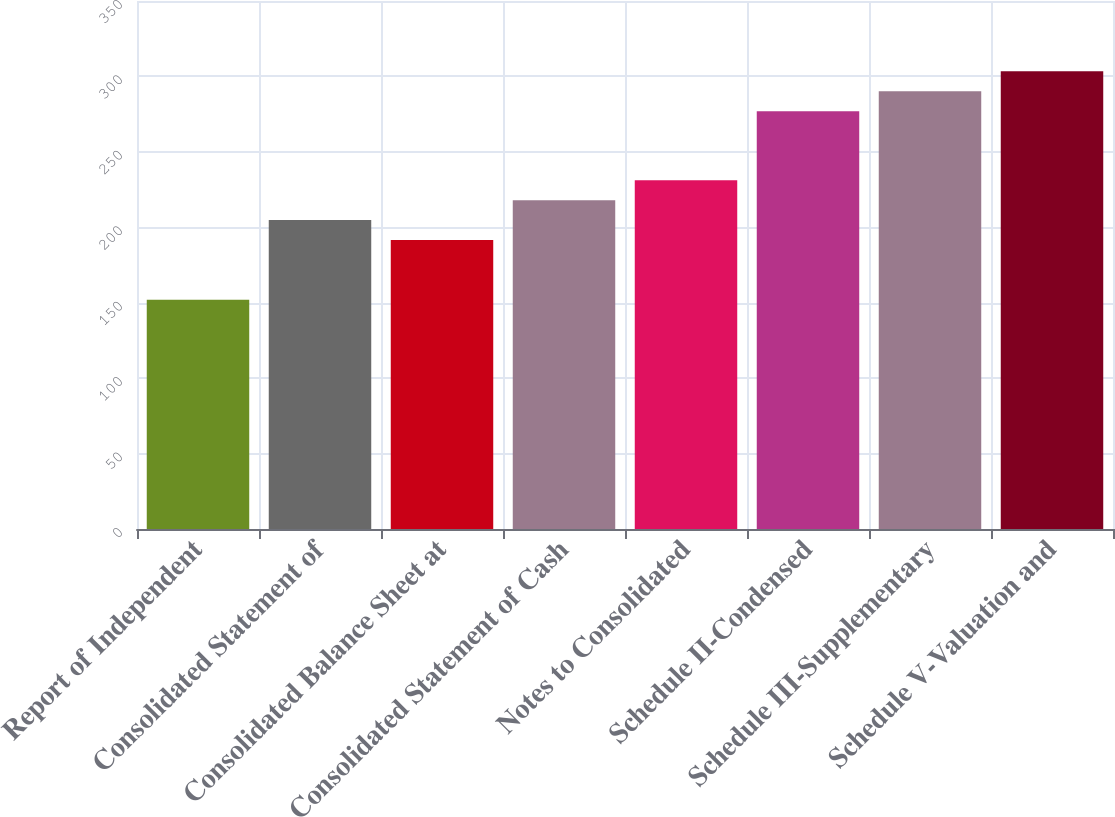<chart> <loc_0><loc_0><loc_500><loc_500><bar_chart><fcel>Report of Independent<fcel>Consolidated Statement of<fcel>Consolidated Balance Sheet at<fcel>Consolidated Statement of Cash<fcel>Notes to Consolidated<fcel>Schedule II-Condensed<fcel>Schedule III-Supplementary<fcel>Schedule V-Valuation and<nl><fcel>152<fcel>204.8<fcel>191.6<fcel>218<fcel>231.2<fcel>277<fcel>290.2<fcel>303.4<nl></chart> 